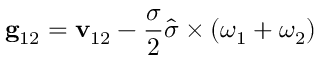Convert formula to latex. <formula><loc_0><loc_0><loc_500><loc_500>g _ { 1 2 } = v _ { 1 2 } - \frac { \sigma } { 2 } \widehat { \sigma } \times ( \omega _ { 1 } + \omega _ { 2 } )</formula> 